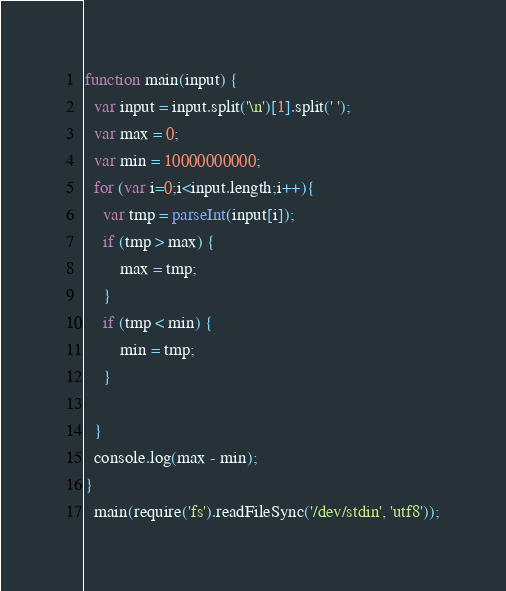<code> <loc_0><loc_0><loc_500><loc_500><_JavaScript_>function main(input) {
  var input = input.split('\n')[1].split(' ');
  var max = 0;
  var min = 10000000000;
  for (var i=0;i<input.length;i++){
  	var tmp = parseInt(input[i]);
  	if (tmp > max) {
  		max = tmp;
  	}
  	if (tmp < min) {
  		min = tmp;
  	}
   	
  }
  console.log(max - min);
}
  main(require('fs').readFileSync('/dev/stdin', 'utf8'));</code> 